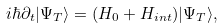<formula> <loc_0><loc_0><loc_500><loc_500>i \hbar { \partial } _ { t } | { \Psi } _ { T } \rangle = ( H _ { 0 } + H _ { i n t } ) | { \Psi } _ { T } \rangle ,</formula> 